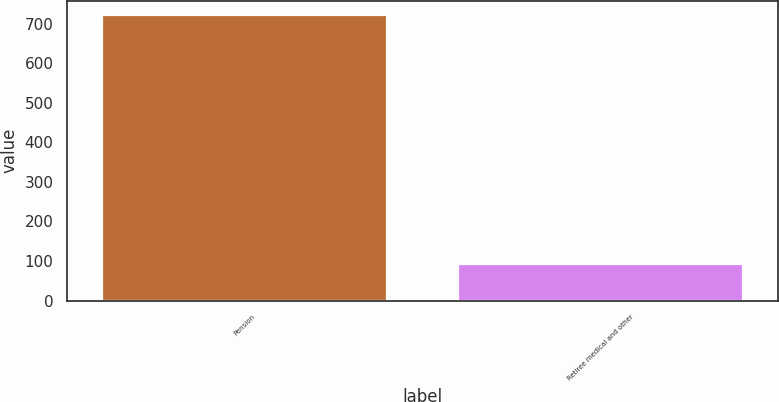Convert chart to OTSL. <chart><loc_0><loc_0><loc_500><loc_500><bar_chart><fcel>Pension<fcel>Retiree medical and other<nl><fcel>722<fcel>93<nl></chart> 